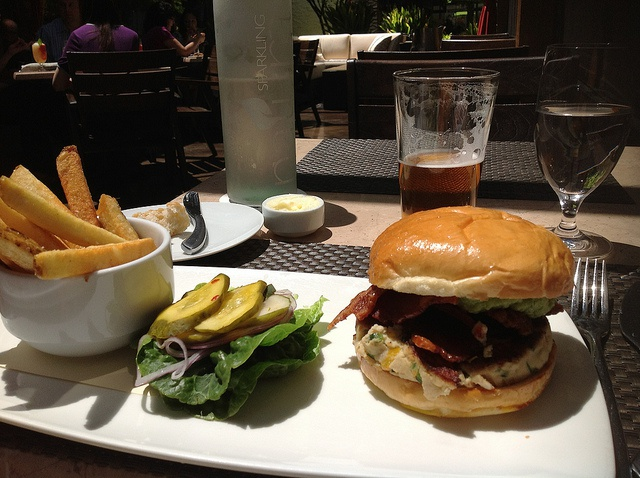Describe the objects in this image and their specific colors. I can see dining table in black, ivory, gray, and olive tones, sandwich in black, olive, maroon, and orange tones, dining table in black, gray, and tan tones, bottle in black and gray tones, and bowl in black, gray, and olive tones in this image. 